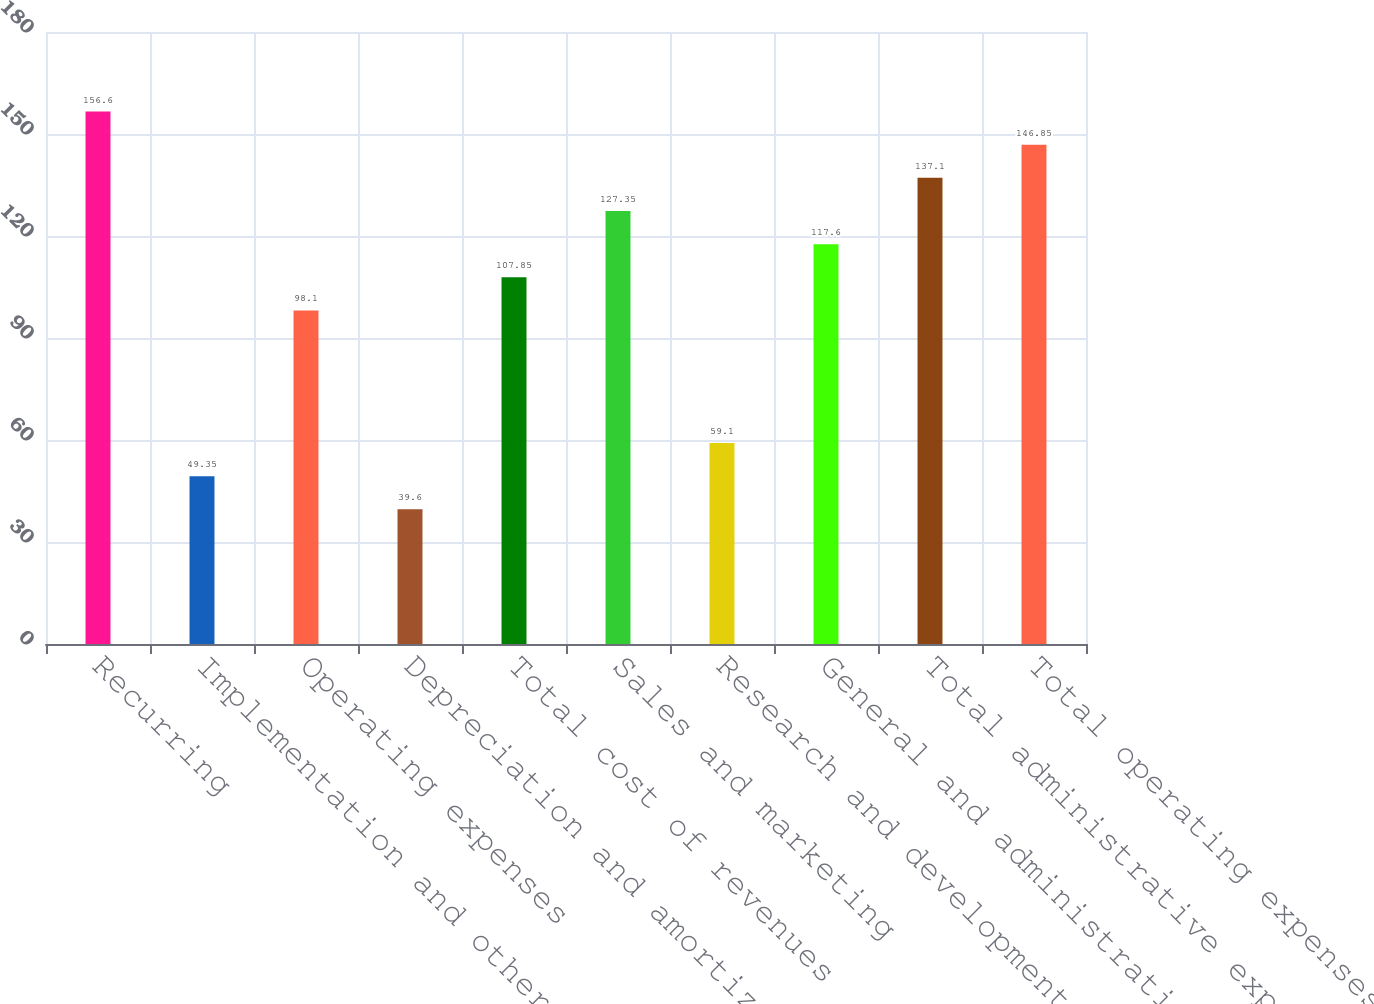Convert chart to OTSL. <chart><loc_0><loc_0><loc_500><loc_500><bar_chart><fcel>Recurring<fcel>Implementation and other<fcel>Operating expenses<fcel>Depreciation and amortization<fcel>Total cost of revenues<fcel>Sales and marketing<fcel>Research and development<fcel>General and administrative<fcel>Total administrative expenses<fcel>Total operating expenses<nl><fcel>156.6<fcel>49.35<fcel>98.1<fcel>39.6<fcel>107.85<fcel>127.35<fcel>59.1<fcel>117.6<fcel>137.1<fcel>146.85<nl></chart> 